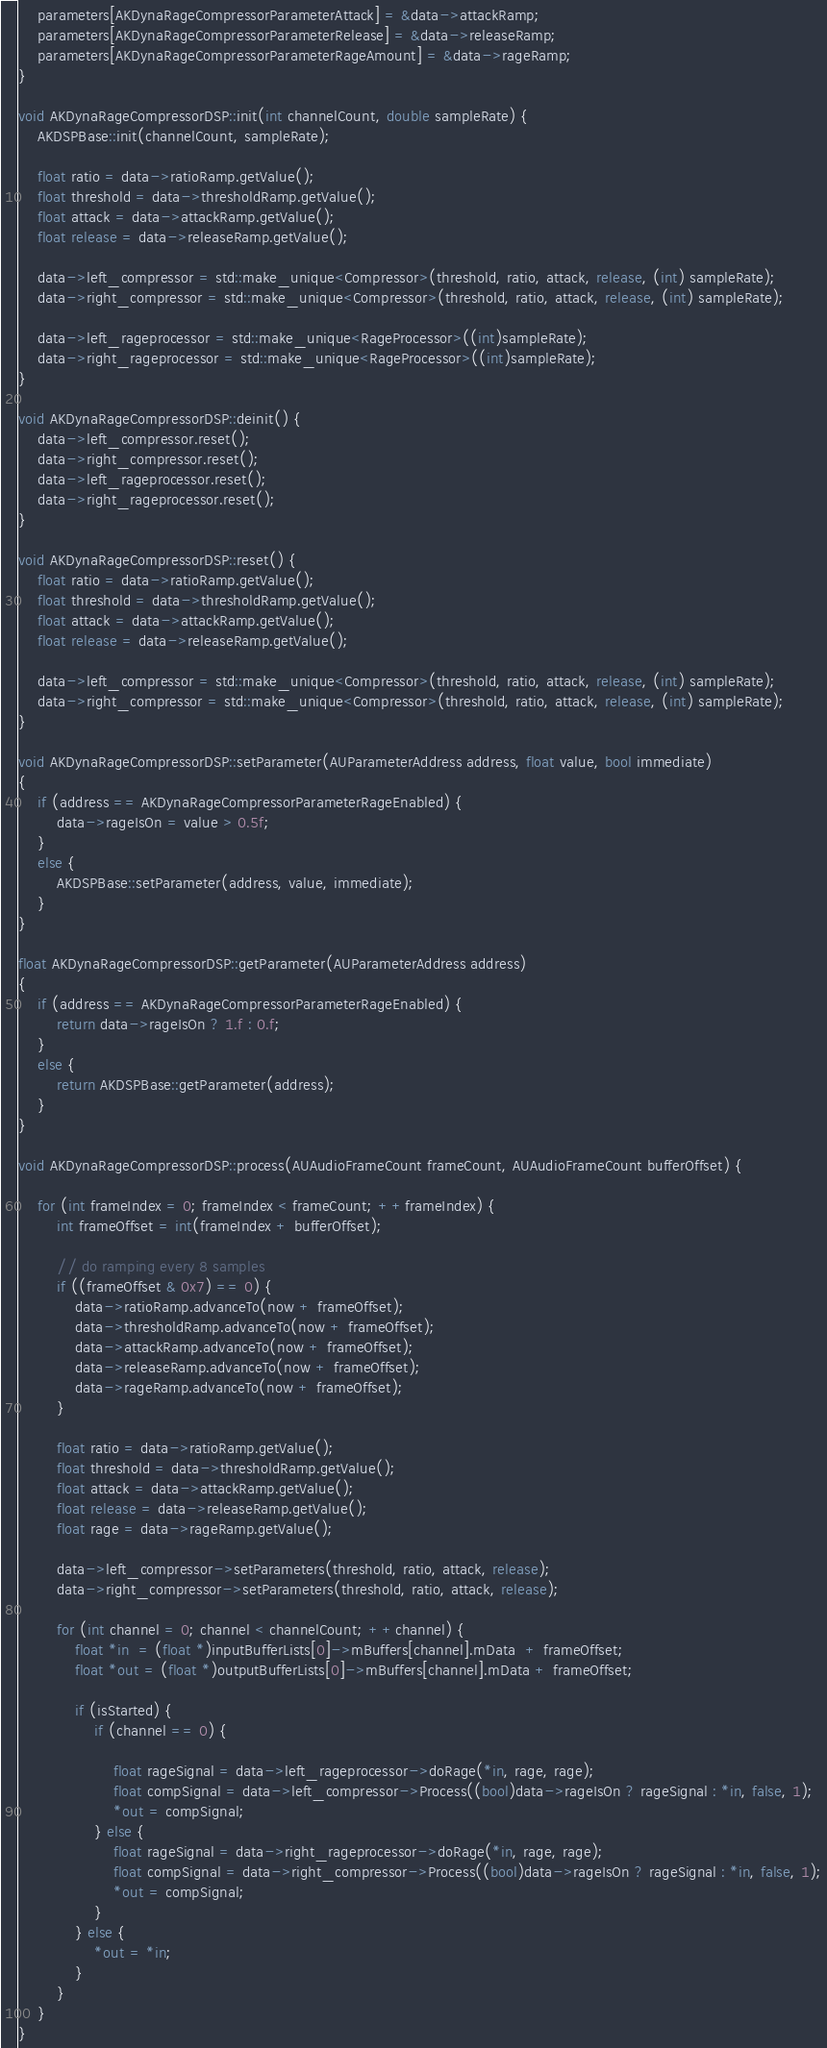Convert code to text. <code><loc_0><loc_0><loc_500><loc_500><_ObjectiveC_>    parameters[AKDynaRageCompressorParameterAttack] = &data->attackRamp;
    parameters[AKDynaRageCompressorParameterRelease] = &data->releaseRamp;
    parameters[AKDynaRageCompressorParameterRageAmount] = &data->rageRamp;
}

void AKDynaRageCompressorDSP::init(int channelCount, double sampleRate) {
    AKDSPBase::init(channelCount, sampleRate);
    
    float ratio = data->ratioRamp.getValue();
    float threshold = data->thresholdRamp.getValue();
    float attack = data->attackRamp.getValue();
    float release = data->releaseRamp.getValue();
    
    data->left_compressor = std::make_unique<Compressor>(threshold, ratio, attack, release, (int) sampleRate);
    data->right_compressor = std::make_unique<Compressor>(threshold, ratio, attack, release, (int) sampleRate);
    
    data->left_rageprocessor = std::make_unique<RageProcessor>((int)sampleRate);
    data->right_rageprocessor = std::make_unique<RageProcessor>((int)sampleRate);
}

void AKDynaRageCompressorDSP::deinit() {
    data->left_compressor.reset();
    data->right_compressor.reset();
    data->left_rageprocessor.reset();
    data->right_rageprocessor.reset();
}

void AKDynaRageCompressorDSP::reset() {
    float ratio = data->ratioRamp.getValue();
    float threshold = data->thresholdRamp.getValue();
    float attack = data->attackRamp.getValue();
    float release = data->releaseRamp.getValue();
    
    data->left_compressor = std::make_unique<Compressor>(threshold, ratio, attack, release, (int) sampleRate);
    data->right_compressor = std::make_unique<Compressor>(threshold, ratio, attack, release, (int) sampleRate);
}

void AKDynaRageCompressorDSP::setParameter(AUParameterAddress address, float value, bool immediate)
{
    if (address == AKDynaRageCompressorParameterRageEnabled) {
        data->rageIsOn = value > 0.5f;
    }
    else {
        AKDSPBase::setParameter(address, value, immediate);
    }
}

float AKDynaRageCompressorDSP::getParameter(AUParameterAddress address)
{
    if (address == AKDynaRageCompressorParameterRageEnabled) {
        return data->rageIsOn ? 1.f : 0.f;
    }
    else {
        return AKDSPBase::getParameter(address);
    }
}

void AKDynaRageCompressorDSP::process(AUAudioFrameCount frameCount, AUAudioFrameCount bufferOffset) {

    for (int frameIndex = 0; frameIndex < frameCount; ++frameIndex) {
        int frameOffset = int(frameIndex + bufferOffset);

        // do ramping every 8 samples
        if ((frameOffset & 0x7) == 0) {
            data->ratioRamp.advanceTo(now + frameOffset);
            data->thresholdRamp.advanceTo(now + frameOffset);
            data->attackRamp.advanceTo(now + frameOffset);
            data->releaseRamp.advanceTo(now + frameOffset);
            data->rageRamp.advanceTo(now + frameOffset);
        }
        
        float ratio = data->ratioRamp.getValue();
        float threshold = data->thresholdRamp.getValue();
        float attack = data->attackRamp.getValue();
        float release = data->releaseRamp.getValue();
        float rage = data->rageRamp.getValue();

        data->left_compressor->setParameters(threshold, ratio, attack, release);
        data->right_compressor->setParameters(threshold, ratio, attack, release);

        for (int channel = 0; channel < channelCount; ++channel) {
            float *in  = (float *)inputBufferLists[0]->mBuffers[channel].mData  + frameOffset;
            float *out = (float *)outputBufferLists[0]->mBuffers[channel].mData + frameOffset;

            if (isStarted) {
                if (channel == 0) {

                    float rageSignal = data->left_rageprocessor->doRage(*in, rage, rage);
                    float compSignal = data->left_compressor->Process((bool)data->rageIsOn ? rageSignal : *in, false, 1);
                    *out = compSignal;
                } else {
                    float rageSignal = data->right_rageprocessor->doRage(*in, rage, rage);
                    float compSignal = data->right_compressor->Process((bool)data->rageIsOn ? rageSignal : *in, false, 1);
                    *out = compSignal;
                }
            } else {
                *out = *in;
            }
        }
    }
}
</code> 